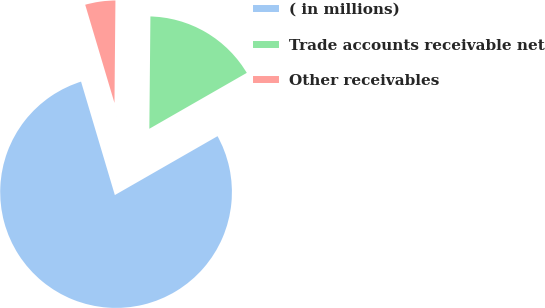<chart> <loc_0><loc_0><loc_500><loc_500><pie_chart><fcel>( in millions)<fcel>Trade accounts receivable net<fcel>Other receivables<nl><fcel>78.68%<fcel>16.56%<fcel>4.76%<nl></chart> 